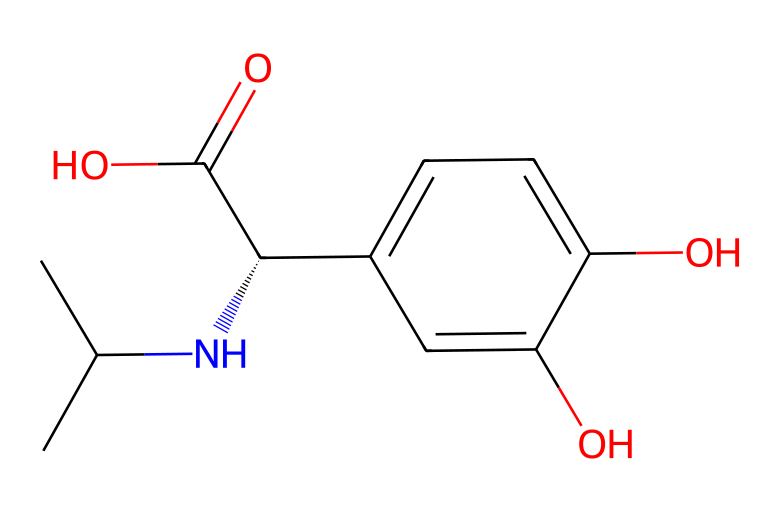What is the total number of carbon atoms in this molecule? By analyzing the SMILES representation (CC(C)N[C@@H](c1ccc(O)c(O)c1)C(=O)O), we can count the number of carbon (C) atoms. The 'C' characters represent carbon atoms, and by counting them in the structure, we find there are 12 carbon atoms.
Answer: 12 How many hydroxyl (OH) groups are present in the structure? In the provided structure, the 'O' atoms connected to 'H' represent hydroxyl groups. The two 'O' atoms in 'c1ccc(O)c(O)' indicate there are two hydroxyl (OH) groups.
Answer: 2 What type of functional group is represented by "C(=O)O"? The notation "C(=O)O" indicates a carboxylic acid functional group, where the carbon is double-bonded to oxygen and single-bonded to a hydroxyl group. This makes it recognizable as a carboxylic acid.
Answer: carboxylic acid What is the stereochemistry at the chiral center indicated by "[C@@H]"? The "[C@@H]" notation shows that there is a chiral center with a specific stereochemistry, designated as S (or R), depending on the arrangement of substituents around the carbon. Since it is labeled with "@@", it specifies the absolute configuration for one steroisomer out of two possible forms.
Answer: S What type of drug is this molecule classified as? Given the structure contains an antihistamine nature linked with histamine receptor antagonism, in combination with hydroxyl and amine groups, it can be classified specifically as an antihistamine drug.
Answer: antihistamine What is the molecular weight of this compound? To determine the molecular weight, we need to sum the atomic weights of all atoms in the structure based on their counts: carbon (C) has an average weight of 12.01 g/mol, nitrogen (N) is about 14.01 g/mol, oxygen (O) is around 16.00 g/mol, and hydrogen (H) is approximately 1.01 g/mol. Calculating yields a total molecular weight of about 224.25 g/mol.
Answer: 224.25 